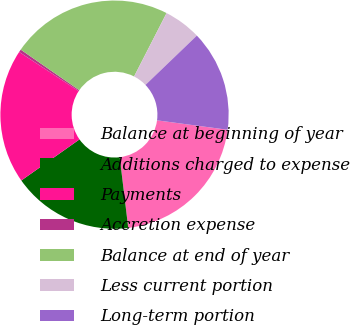Convert chart. <chart><loc_0><loc_0><loc_500><loc_500><pie_chart><fcel>Balance at beginning of year<fcel>Additions charged to expense<fcel>Payments<fcel>Accretion expense<fcel>Balance at end of year<fcel>Less current portion<fcel>Long-term portion<nl><fcel>20.97%<fcel>17.13%<fcel>19.05%<fcel>0.39%<fcel>22.89%<fcel>5.29%<fcel>14.29%<nl></chart> 